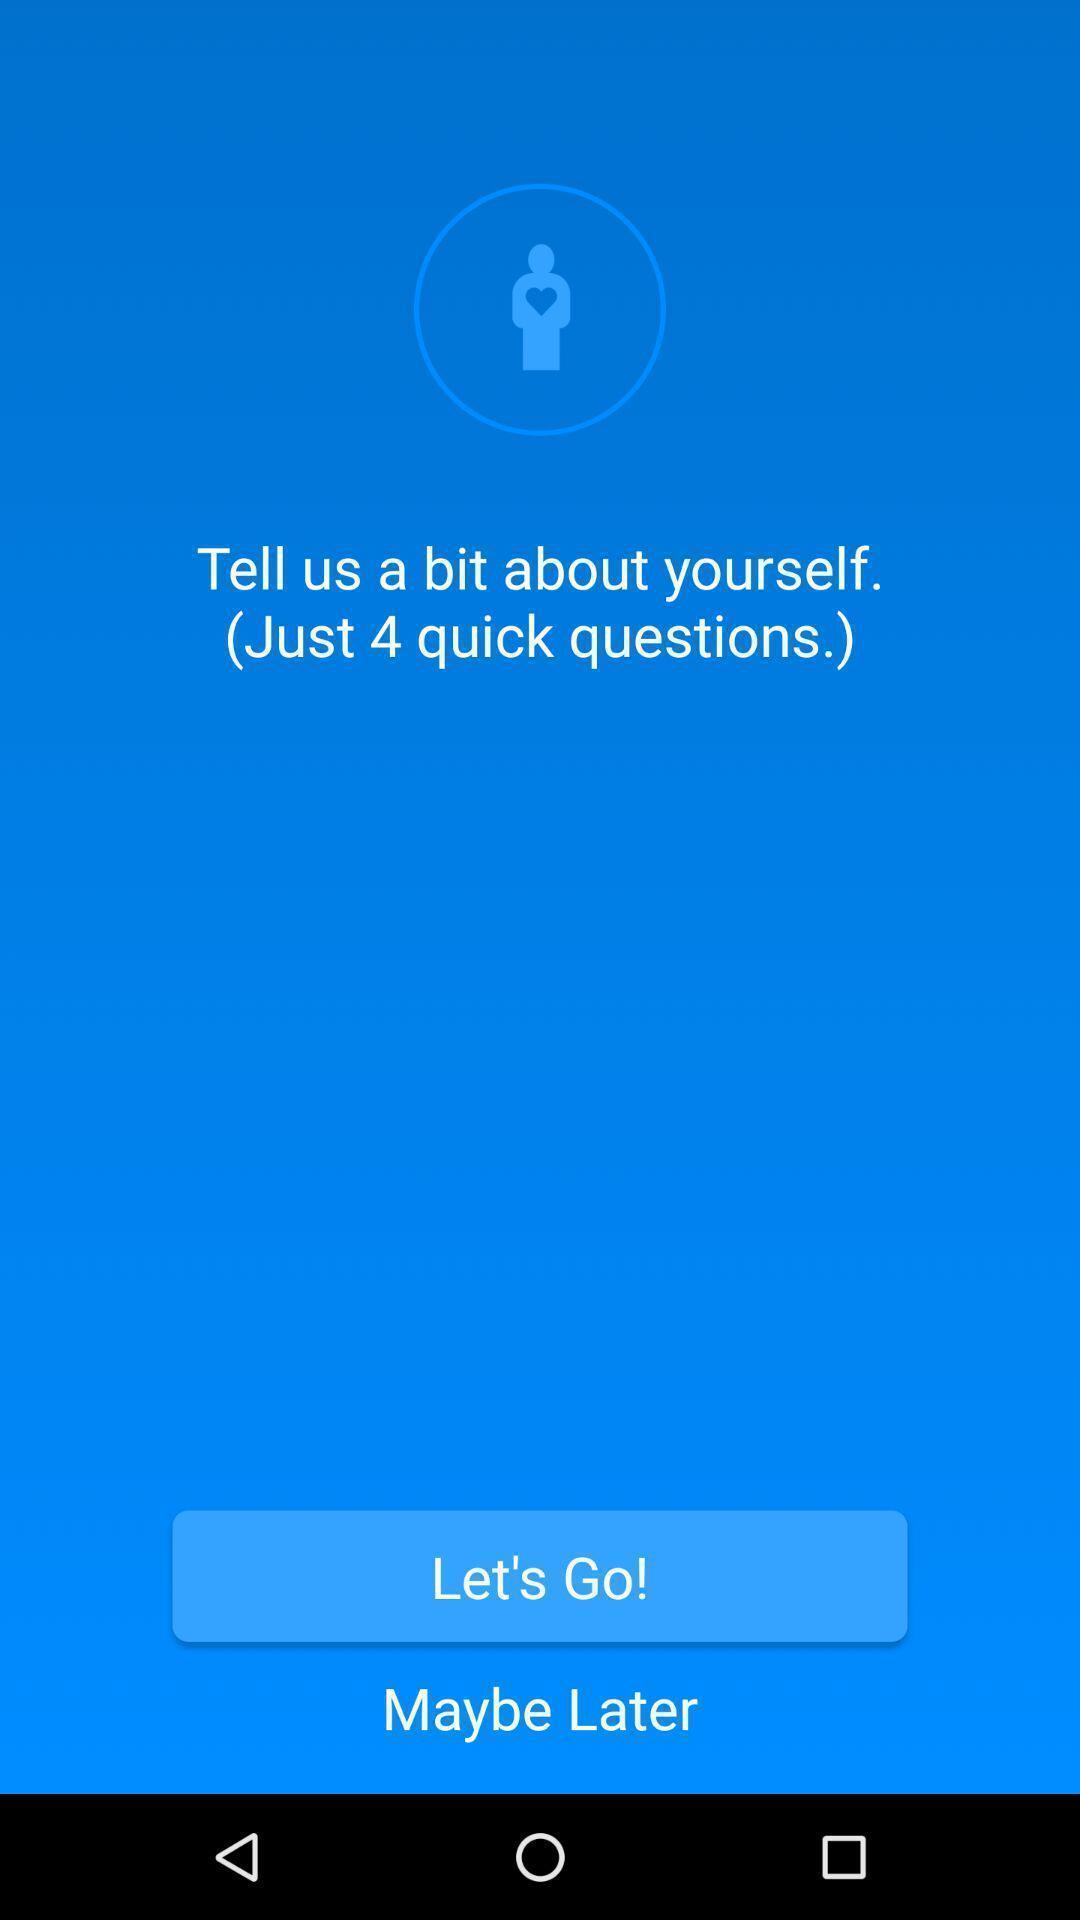Describe this image in words. Welcome page to the application with options. 